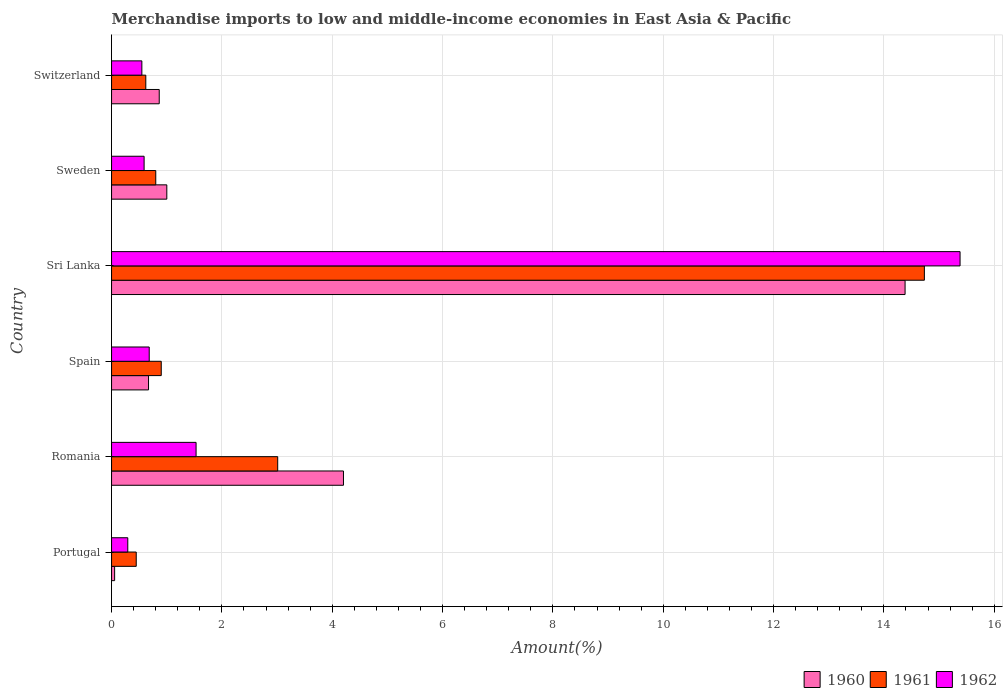Are the number of bars per tick equal to the number of legend labels?
Ensure brevity in your answer.  Yes. Are the number of bars on each tick of the Y-axis equal?
Keep it short and to the point. Yes. How many bars are there on the 6th tick from the top?
Keep it short and to the point. 3. In how many cases, is the number of bars for a given country not equal to the number of legend labels?
Provide a short and direct response. 0. What is the percentage of amount earned from merchandise imports in 1962 in Switzerland?
Your response must be concise. 0.55. Across all countries, what is the maximum percentage of amount earned from merchandise imports in 1962?
Offer a terse response. 15.38. Across all countries, what is the minimum percentage of amount earned from merchandise imports in 1962?
Ensure brevity in your answer.  0.29. In which country was the percentage of amount earned from merchandise imports in 1962 maximum?
Offer a very short reply. Sri Lanka. In which country was the percentage of amount earned from merchandise imports in 1961 minimum?
Ensure brevity in your answer.  Portugal. What is the total percentage of amount earned from merchandise imports in 1962 in the graph?
Offer a very short reply. 19.03. What is the difference between the percentage of amount earned from merchandise imports in 1961 in Portugal and that in Switzerland?
Your answer should be compact. -0.17. What is the difference between the percentage of amount earned from merchandise imports in 1961 in Romania and the percentage of amount earned from merchandise imports in 1960 in Portugal?
Provide a short and direct response. 2.96. What is the average percentage of amount earned from merchandise imports in 1962 per country?
Provide a succinct answer. 3.17. What is the difference between the percentage of amount earned from merchandise imports in 1962 and percentage of amount earned from merchandise imports in 1960 in Sweden?
Give a very brief answer. -0.41. What is the ratio of the percentage of amount earned from merchandise imports in 1960 in Spain to that in Switzerland?
Ensure brevity in your answer.  0.78. Is the percentage of amount earned from merchandise imports in 1962 in Spain less than that in Sri Lanka?
Your response must be concise. Yes. What is the difference between the highest and the second highest percentage of amount earned from merchandise imports in 1961?
Provide a short and direct response. 11.72. What is the difference between the highest and the lowest percentage of amount earned from merchandise imports in 1960?
Ensure brevity in your answer.  14.33. In how many countries, is the percentage of amount earned from merchandise imports in 1962 greater than the average percentage of amount earned from merchandise imports in 1962 taken over all countries?
Your response must be concise. 1. Is the sum of the percentage of amount earned from merchandise imports in 1962 in Sri Lanka and Sweden greater than the maximum percentage of amount earned from merchandise imports in 1960 across all countries?
Ensure brevity in your answer.  Yes. What does the 1st bar from the bottom in Switzerland represents?
Offer a terse response. 1960. How many countries are there in the graph?
Your answer should be compact. 6. Does the graph contain any zero values?
Your response must be concise. No. Where does the legend appear in the graph?
Your answer should be compact. Bottom right. How are the legend labels stacked?
Your response must be concise. Horizontal. What is the title of the graph?
Your answer should be compact. Merchandise imports to low and middle-income economies in East Asia & Pacific. What is the label or title of the X-axis?
Ensure brevity in your answer.  Amount(%). What is the label or title of the Y-axis?
Provide a short and direct response. Country. What is the Amount(%) in 1960 in Portugal?
Provide a succinct answer. 0.06. What is the Amount(%) in 1961 in Portugal?
Your answer should be compact. 0.45. What is the Amount(%) of 1962 in Portugal?
Keep it short and to the point. 0.29. What is the Amount(%) in 1960 in Romania?
Offer a terse response. 4.2. What is the Amount(%) in 1961 in Romania?
Provide a short and direct response. 3.01. What is the Amount(%) of 1962 in Romania?
Your answer should be very brief. 1.53. What is the Amount(%) in 1960 in Spain?
Offer a terse response. 0.67. What is the Amount(%) of 1961 in Spain?
Provide a short and direct response. 0.9. What is the Amount(%) in 1962 in Spain?
Ensure brevity in your answer.  0.68. What is the Amount(%) of 1960 in Sri Lanka?
Your response must be concise. 14.38. What is the Amount(%) in 1961 in Sri Lanka?
Your answer should be compact. 14.73. What is the Amount(%) in 1962 in Sri Lanka?
Offer a very short reply. 15.38. What is the Amount(%) in 1960 in Sweden?
Offer a terse response. 1. What is the Amount(%) of 1961 in Sweden?
Provide a short and direct response. 0.8. What is the Amount(%) in 1962 in Sweden?
Ensure brevity in your answer.  0.59. What is the Amount(%) of 1960 in Switzerland?
Make the answer very short. 0.86. What is the Amount(%) in 1961 in Switzerland?
Provide a short and direct response. 0.62. What is the Amount(%) of 1962 in Switzerland?
Your answer should be very brief. 0.55. Across all countries, what is the maximum Amount(%) of 1960?
Your answer should be very brief. 14.38. Across all countries, what is the maximum Amount(%) of 1961?
Offer a terse response. 14.73. Across all countries, what is the maximum Amount(%) of 1962?
Provide a succinct answer. 15.38. Across all countries, what is the minimum Amount(%) of 1960?
Provide a short and direct response. 0.06. Across all countries, what is the minimum Amount(%) of 1961?
Provide a short and direct response. 0.45. Across all countries, what is the minimum Amount(%) of 1962?
Ensure brevity in your answer.  0.29. What is the total Amount(%) in 1960 in the graph?
Give a very brief answer. 21.18. What is the total Amount(%) of 1961 in the graph?
Ensure brevity in your answer.  20.52. What is the total Amount(%) of 1962 in the graph?
Your response must be concise. 19.03. What is the difference between the Amount(%) in 1960 in Portugal and that in Romania?
Offer a very short reply. -4.15. What is the difference between the Amount(%) of 1961 in Portugal and that in Romania?
Your answer should be very brief. -2.56. What is the difference between the Amount(%) in 1962 in Portugal and that in Romania?
Offer a very short reply. -1.24. What is the difference between the Amount(%) in 1960 in Portugal and that in Spain?
Make the answer very short. -0.61. What is the difference between the Amount(%) in 1961 in Portugal and that in Spain?
Make the answer very short. -0.45. What is the difference between the Amount(%) in 1962 in Portugal and that in Spain?
Keep it short and to the point. -0.39. What is the difference between the Amount(%) in 1960 in Portugal and that in Sri Lanka?
Your answer should be compact. -14.33. What is the difference between the Amount(%) of 1961 in Portugal and that in Sri Lanka?
Ensure brevity in your answer.  -14.29. What is the difference between the Amount(%) of 1962 in Portugal and that in Sri Lanka?
Your answer should be very brief. -15.09. What is the difference between the Amount(%) of 1960 in Portugal and that in Sweden?
Your answer should be very brief. -0.95. What is the difference between the Amount(%) of 1961 in Portugal and that in Sweden?
Offer a terse response. -0.35. What is the difference between the Amount(%) in 1962 in Portugal and that in Sweden?
Give a very brief answer. -0.3. What is the difference between the Amount(%) of 1960 in Portugal and that in Switzerland?
Keep it short and to the point. -0.81. What is the difference between the Amount(%) in 1961 in Portugal and that in Switzerland?
Give a very brief answer. -0.17. What is the difference between the Amount(%) in 1962 in Portugal and that in Switzerland?
Offer a terse response. -0.26. What is the difference between the Amount(%) of 1960 in Romania and that in Spain?
Make the answer very short. 3.53. What is the difference between the Amount(%) of 1961 in Romania and that in Spain?
Your answer should be very brief. 2.11. What is the difference between the Amount(%) of 1962 in Romania and that in Spain?
Provide a short and direct response. 0.85. What is the difference between the Amount(%) in 1960 in Romania and that in Sri Lanka?
Your answer should be very brief. -10.18. What is the difference between the Amount(%) of 1961 in Romania and that in Sri Lanka?
Provide a succinct answer. -11.72. What is the difference between the Amount(%) in 1962 in Romania and that in Sri Lanka?
Make the answer very short. -13.85. What is the difference between the Amount(%) of 1960 in Romania and that in Sweden?
Make the answer very short. 3.2. What is the difference between the Amount(%) of 1961 in Romania and that in Sweden?
Give a very brief answer. 2.21. What is the difference between the Amount(%) in 1962 in Romania and that in Sweden?
Make the answer very short. 0.94. What is the difference between the Amount(%) of 1960 in Romania and that in Switzerland?
Provide a short and direct response. 3.34. What is the difference between the Amount(%) in 1961 in Romania and that in Switzerland?
Provide a short and direct response. 2.39. What is the difference between the Amount(%) of 1962 in Romania and that in Switzerland?
Offer a terse response. 0.98. What is the difference between the Amount(%) of 1960 in Spain and that in Sri Lanka?
Give a very brief answer. -13.71. What is the difference between the Amount(%) in 1961 in Spain and that in Sri Lanka?
Provide a succinct answer. -13.83. What is the difference between the Amount(%) in 1962 in Spain and that in Sri Lanka?
Provide a short and direct response. -14.7. What is the difference between the Amount(%) of 1960 in Spain and that in Sweden?
Provide a succinct answer. -0.33. What is the difference between the Amount(%) of 1961 in Spain and that in Sweden?
Your answer should be very brief. 0.1. What is the difference between the Amount(%) in 1962 in Spain and that in Sweden?
Your answer should be compact. 0.09. What is the difference between the Amount(%) of 1960 in Spain and that in Switzerland?
Give a very brief answer. -0.19. What is the difference between the Amount(%) in 1961 in Spain and that in Switzerland?
Provide a short and direct response. 0.28. What is the difference between the Amount(%) in 1962 in Spain and that in Switzerland?
Provide a short and direct response. 0.13. What is the difference between the Amount(%) in 1960 in Sri Lanka and that in Sweden?
Keep it short and to the point. 13.38. What is the difference between the Amount(%) in 1961 in Sri Lanka and that in Sweden?
Offer a terse response. 13.93. What is the difference between the Amount(%) in 1962 in Sri Lanka and that in Sweden?
Your response must be concise. 14.79. What is the difference between the Amount(%) in 1960 in Sri Lanka and that in Switzerland?
Keep it short and to the point. 13.52. What is the difference between the Amount(%) of 1961 in Sri Lanka and that in Switzerland?
Make the answer very short. 14.11. What is the difference between the Amount(%) of 1962 in Sri Lanka and that in Switzerland?
Offer a very short reply. 14.83. What is the difference between the Amount(%) of 1960 in Sweden and that in Switzerland?
Offer a terse response. 0.14. What is the difference between the Amount(%) in 1961 in Sweden and that in Switzerland?
Your answer should be very brief. 0.18. What is the difference between the Amount(%) of 1962 in Sweden and that in Switzerland?
Keep it short and to the point. 0.04. What is the difference between the Amount(%) in 1960 in Portugal and the Amount(%) in 1961 in Romania?
Your response must be concise. -2.96. What is the difference between the Amount(%) of 1960 in Portugal and the Amount(%) of 1962 in Romania?
Your response must be concise. -1.48. What is the difference between the Amount(%) of 1961 in Portugal and the Amount(%) of 1962 in Romania?
Your answer should be compact. -1.08. What is the difference between the Amount(%) of 1960 in Portugal and the Amount(%) of 1961 in Spain?
Keep it short and to the point. -0.85. What is the difference between the Amount(%) in 1960 in Portugal and the Amount(%) in 1962 in Spain?
Give a very brief answer. -0.63. What is the difference between the Amount(%) of 1961 in Portugal and the Amount(%) of 1962 in Spain?
Offer a terse response. -0.24. What is the difference between the Amount(%) in 1960 in Portugal and the Amount(%) in 1961 in Sri Lanka?
Keep it short and to the point. -14.68. What is the difference between the Amount(%) of 1960 in Portugal and the Amount(%) of 1962 in Sri Lanka?
Provide a succinct answer. -15.32. What is the difference between the Amount(%) in 1961 in Portugal and the Amount(%) in 1962 in Sri Lanka?
Your answer should be very brief. -14.93. What is the difference between the Amount(%) in 1960 in Portugal and the Amount(%) in 1961 in Sweden?
Give a very brief answer. -0.75. What is the difference between the Amount(%) in 1960 in Portugal and the Amount(%) in 1962 in Sweden?
Offer a terse response. -0.53. What is the difference between the Amount(%) of 1961 in Portugal and the Amount(%) of 1962 in Sweden?
Ensure brevity in your answer.  -0.14. What is the difference between the Amount(%) of 1960 in Portugal and the Amount(%) of 1961 in Switzerland?
Your answer should be very brief. -0.56. What is the difference between the Amount(%) of 1960 in Portugal and the Amount(%) of 1962 in Switzerland?
Your response must be concise. -0.49. What is the difference between the Amount(%) in 1961 in Portugal and the Amount(%) in 1962 in Switzerland?
Offer a very short reply. -0.1. What is the difference between the Amount(%) in 1960 in Romania and the Amount(%) in 1961 in Spain?
Provide a succinct answer. 3.3. What is the difference between the Amount(%) of 1960 in Romania and the Amount(%) of 1962 in Spain?
Your response must be concise. 3.52. What is the difference between the Amount(%) in 1961 in Romania and the Amount(%) in 1962 in Spain?
Your answer should be compact. 2.33. What is the difference between the Amount(%) in 1960 in Romania and the Amount(%) in 1961 in Sri Lanka?
Give a very brief answer. -10.53. What is the difference between the Amount(%) in 1960 in Romania and the Amount(%) in 1962 in Sri Lanka?
Make the answer very short. -11.18. What is the difference between the Amount(%) of 1961 in Romania and the Amount(%) of 1962 in Sri Lanka?
Offer a very short reply. -12.37. What is the difference between the Amount(%) in 1960 in Romania and the Amount(%) in 1961 in Sweden?
Offer a terse response. 3.4. What is the difference between the Amount(%) of 1960 in Romania and the Amount(%) of 1962 in Sweden?
Offer a very short reply. 3.61. What is the difference between the Amount(%) of 1961 in Romania and the Amount(%) of 1962 in Sweden?
Your answer should be compact. 2.42. What is the difference between the Amount(%) of 1960 in Romania and the Amount(%) of 1961 in Switzerland?
Ensure brevity in your answer.  3.58. What is the difference between the Amount(%) of 1960 in Romania and the Amount(%) of 1962 in Switzerland?
Provide a succinct answer. 3.65. What is the difference between the Amount(%) of 1961 in Romania and the Amount(%) of 1962 in Switzerland?
Provide a succinct answer. 2.46. What is the difference between the Amount(%) in 1960 in Spain and the Amount(%) in 1961 in Sri Lanka?
Provide a succinct answer. -14.06. What is the difference between the Amount(%) in 1960 in Spain and the Amount(%) in 1962 in Sri Lanka?
Keep it short and to the point. -14.71. What is the difference between the Amount(%) of 1961 in Spain and the Amount(%) of 1962 in Sri Lanka?
Provide a short and direct response. -14.48. What is the difference between the Amount(%) in 1960 in Spain and the Amount(%) in 1961 in Sweden?
Provide a succinct answer. -0.13. What is the difference between the Amount(%) of 1960 in Spain and the Amount(%) of 1962 in Sweden?
Your answer should be compact. 0.08. What is the difference between the Amount(%) in 1961 in Spain and the Amount(%) in 1962 in Sweden?
Make the answer very short. 0.31. What is the difference between the Amount(%) of 1960 in Spain and the Amount(%) of 1961 in Switzerland?
Your answer should be compact. 0.05. What is the difference between the Amount(%) in 1960 in Spain and the Amount(%) in 1962 in Switzerland?
Provide a short and direct response. 0.12. What is the difference between the Amount(%) in 1961 in Spain and the Amount(%) in 1962 in Switzerland?
Give a very brief answer. 0.35. What is the difference between the Amount(%) in 1960 in Sri Lanka and the Amount(%) in 1961 in Sweden?
Offer a terse response. 13.58. What is the difference between the Amount(%) in 1960 in Sri Lanka and the Amount(%) in 1962 in Sweden?
Offer a very short reply. 13.79. What is the difference between the Amount(%) in 1961 in Sri Lanka and the Amount(%) in 1962 in Sweden?
Provide a short and direct response. 14.14. What is the difference between the Amount(%) of 1960 in Sri Lanka and the Amount(%) of 1961 in Switzerland?
Make the answer very short. 13.76. What is the difference between the Amount(%) of 1960 in Sri Lanka and the Amount(%) of 1962 in Switzerland?
Give a very brief answer. 13.83. What is the difference between the Amount(%) in 1961 in Sri Lanka and the Amount(%) in 1962 in Switzerland?
Offer a terse response. 14.18. What is the difference between the Amount(%) of 1960 in Sweden and the Amount(%) of 1961 in Switzerland?
Ensure brevity in your answer.  0.38. What is the difference between the Amount(%) in 1960 in Sweden and the Amount(%) in 1962 in Switzerland?
Offer a terse response. 0.45. What is the difference between the Amount(%) in 1961 in Sweden and the Amount(%) in 1962 in Switzerland?
Offer a terse response. 0.25. What is the average Amount(%) of 1960 per country?
Ensure brevity in your answer.  3.53. What is the average Amount(%) of 1961 per country?
Offer a very short reply. 3.42. What is the average Amount(%) of 1962 per country?
Provide a succinct answer. 3.17. What is the difference between the Amount(%) of 1960 and Amount(%) of 1961 in Portugal?
Provide a succinct answer. -0.39. What is the difference between the Amount(%) of 1960 and Amount(%) of 1962 in Portugal?
Offer a very short reply. -0.24. What is the difference between the Amount(%) of 1961 and Amount(%) of 1962 in Portugal?
Your response must be concise. 0.15. What is the difference between the Amount(%) of 1960 and Amount(%) of 1961 in Romania?
Provide a short and direct response. 1.19. What is the difference between the Amount(%) in 1960 and Amount(%) in 1962 in Romania?
Ensure brevity in your answer.  2.67. What is the difference between the Amount(%) of 1961 and Amount(%) of 1962 in Romania?
Provide a short and direct response. 1.48. What is the difference between the Amount(%) of 1960 and Amount(%) of 1961 in Spain?
Provide a short and direct response. -0.23. What is the difference between the Amount(%) of 1960 and Amount(%) of 1962 in Spain?
Offer a very short reply. -0.01. What is the difference between the Amount(%) of 1961 and Amount(%) of 1962 in Spain?
Your answer should be very brief. 0.22. What is the difference between the Amount(%) of 1960 and Amount(%) of 1961 in Sri Lanka?
Provide a succinct answer. -0.35. What is the difference between the Amount(%) in 1960 and Amount(%) in 1962 in Sri Lanka?
Offer a very short reply. -1. What is the difference between the Amount(%) in 1961 and Amount(%) in 1962 in Sri Lanka?
Make the answer very short. -0.65. What is the difference between the Amount(%) in 1960 and Amount(%) in 1961 in Sweden?
Your answer should be compact. 0.2. What is the difference between the Amount(%) of 1960 and Amount(%) of 1962 in Sweden?
Your answer should be compact. 0.41. What is the difference between the Amount(%) of 1961 and Amount(%) of 1962 in Sweden?
Your answer should be very brief. 0.21. What is the difference between the Amount(%) of 1960 and Amount(%) of 1961 in Switzerland?
Give a very brief answer. 0.24. What is the difference between the Amount(%) in 1960 and Amount(%) in 1962 in Switzerland?
Make the answer very short. 0.31. What is the difference between the Amount(%) of 1961 and Amount(%) of 1962 in Switzerland?
Offer a terse response. 0.07. What is the ratio of the Amount(%) in 1960 in Portugal to that in Romania?
Provide a succinct answer. 0.01. What is the ratio of the Amount(%) of 1961 in Portugal to that in Romania?
Offer a terse response. 0.15. What is the ratio of the Amount(%) of 1962 in Portugal to that in Romania?
Your answer should be very brief. 0.19. What is the ratio of the Amount(%) in 1960 in Portugal to that in Spain?
Ensure brevity in your answer.  0.08. What is the ratio of the Amount(%) of 1961 in Portugal to that in Spain?
Offer a very short reply. 0.5. What is the ratio of the Amount(%) of 1962 in Portugal to that in Spain?
Your answer should be compact. 0.43. What is the ratio of the Amount(%) of 1960 in Portugal to that in Sri Lanka?
Offer a terse response. 0. What is the ratio of the Amount(%) of 1961 in Portugal to that in Sri Lanka?
Keep it short and to the point. 0.03. What is the ratio of the Amount(%) of 1962 in Portugal to that in Sri Lanka?
Make the answer very short. 0.02. What is the ratio of the Amount(%) in 1960 in Portugal to that in Sweden?
Your answer should be compact. 0.06. What is the ratio of the Amount(%) of 1961 in Portugal to that in Sweden?
Your answer should be very brief. 0.56. What is the ratio of the Amount(%) in 1962 in Portugal to that in Sweden?
Make the answer very short. 0.5. What is the ratio of the Amount(%) of 1960 in Portugal to that in Switzerland?
Make the answer very short. 0.06. What is the ratio of the Amount(%) of 1961 in Portugal to that in Switzerland?
Make the answer very short. 0.72. What is the ratio of the Amount(%) of 1962 in Portugal to that in Switzerland?
Give a very brief answer. 0.54. What is the ratio of the Amount(%) in 1960 in Romania to that in Spain?
Offer a terse response. 6.27. What is the ratio of the Amount(%) of 1961 in Romania to that in Spain?
Offer a very short reply. 3.34. What is the ratio of the Amount(%) of 1962 in Romania to that in Spain?
Ensure brevity in your answer.  2.24. What is the ratio of the Amount(%) of 1960 in Romania to that in Sri Lanka?
Provide a short and direct response. 0.29. What is the ratio of the Amount(%) in 1961 in Romania to that in Sri Lanka?
Provide a succinct answer. 0.2. What is the ratio of the Amount(%) in 1962 in Romania to that in Sri Lanka?
Ensure brevity in your answer.  0.1. What is the ratio of the Amount(%) in 1960 in Romania to that in Sweden?
Your answer should be compact. 4.2. What is the ratio of the Amount(%) of 1961 in Romania to that in Sweden?
Your response must be concise. 3.76. What is the ratio of the Amount(%) in 1962 in Romania to that in Sweden?
Give a very brief answer. 2.6. What is the ratio of the Amount(%) of 1960 in Romania to that in Switzerland?
Keep it short and to the point. 4.86. What is the ratio of the Amount(%) of 1961 in Romania to that in Switzerland?
Provide a short and direct response. 4.85. What is the ratio of the Amount(%) of 1962 in Romania to that in Switzerland?
Provide a short and direct response. 2.79. What is the ratio of the Amount(%) in 1960 in Spain to that in Sri Lanka?
Offer a terse response. 0.05. What is the ratio of the Amount(%) in 1961 in Spain to that in Sri Lanka?
Offer a terse response. 0.06. What is the ratio of the Amount(%) in 1962 in Spain to that in Sri Lanka?
Offer a terse response. 0.04. What is the ratio of the Amount(%) of 1960 in Spain to that in Sweden?
Make the answer very short. 0.67. What is the ratio of the Amount(%) in 1961 in Spain to that in Sweden?
Provide a succinct answer. 1.12. What is the ratio of the Amount(%) in 1962 in Spain to that in Sweden?
Your answer should be compact. 1.16. What is the ratio of the Amount(%) of 1960 in Spain to that in Switzerland?
Give a very brief answer. 0.78. What is the ratio of the Amount(%) in 1961 in Spain to that in Switzerland?
Your response must be concise. 1.45. What is the ratio of the Amount(%) in 1962 in Spain to that in Switzerland?
Your response must be concise. 1.24. What is the ratio of the Amount(%) of 1960 in Sri Lanka to that in Sweden?
Offer a terse response. 14.36. What is the ratio of the Amount(%) of 1961 in Sri Lanka to that in Sweden?
Ensure brevity in your answer.  18.38. What is the ratio of the Amount(%) in 1962 in Sri Lanka to that in Sweden?
Make the answer very short. 26.07. What is the ratio of the Amount(%) of 1960 in Sri Lanka to that in Switzerland?
Provide a succinct answer. 16.64. What is the ratio of the Amount(%) in 1961 in Sri Lanka to that in Switzerland?
Give a very brief answer. 23.74. What is the ratio of the Amount(%) in 1962 in Sri Lanka to that in Switzerland?
Offer a very short reply. 28. What is the ratio of the Amount(%) in 1960 in Sweden to that in Switzerland?
Ensure brevity in your answer.  1.16. What is the ratio of the Amount(%) of 1961 in Sweden to that in Switzerland?
Offer a terse response. 1.29. What is the ratio of the Amount(%) of 1962 in Sweden to that in Switzerland?
Give a very brief answer. 1.07. What is the difference between the highest and the second highest Amount(%) in 1960?
Make the answer very short. 10.18. What is the difference between the highest and the second highest Amount(%) of 1961?
Provide a short and direct response. 11.72. What is the difference between the highest and the second highest Amount(%) of 1962?
Ensure brevity in your answer.  13.85. What is the difference between the highest and the lowest Amount(%) of 1960?
Provide a short and direct response. 14.33. What is the difference between the highest and the lowest Amount(%) of 1961?
Your answer should be compact. 14.29. What is the difference between the highest and the lowest Amount(%) in 1962?
Ensure brevity in your answer.  15.09. 